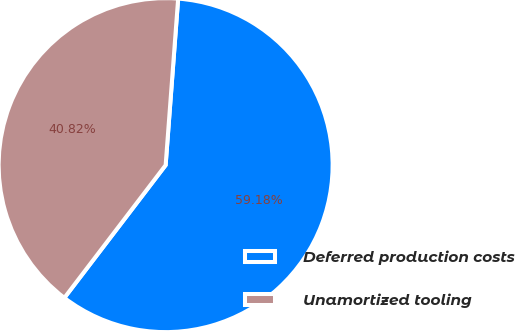<chart> <loc_0><loc_0><loc_500><loc_500><pie_chart><fcel>Deferred production costs<fcel>Unamortized tooling<nl><fcel>59.18%<fcel>40.82%<nl></chart> 